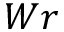<formula> <loc_0><loc_0><loc_500><loc_500>W r</formula> 